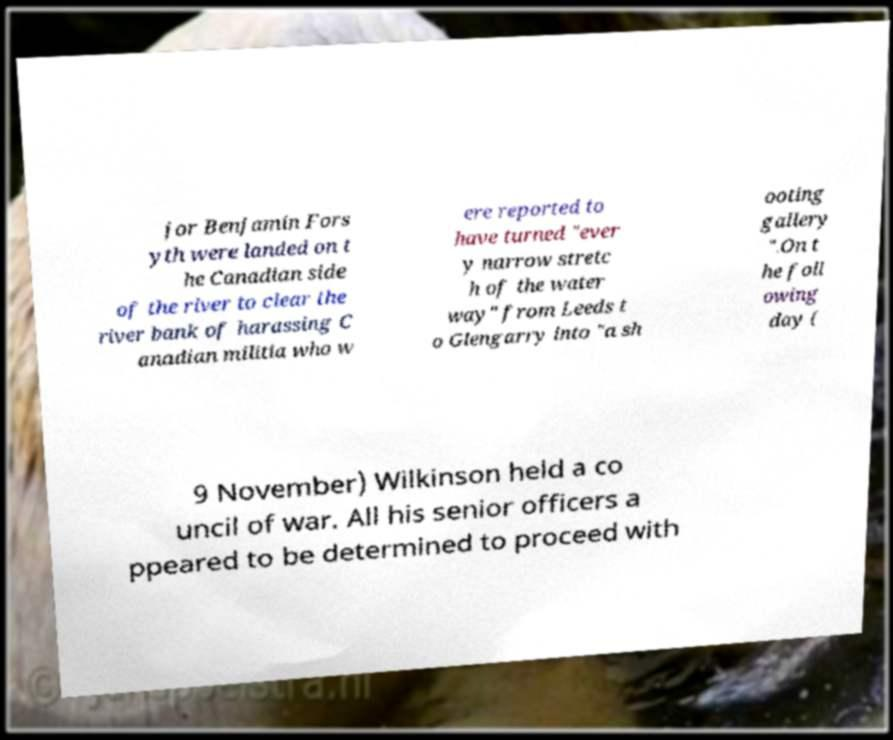Can you accurately transcribe the text from the provided image for me? jor Benjamin Fors yth were landed on t he Canadian side of the river to clear the river bank of harassing C anadian militia who w ere reported to have turned "ever y narrow stretc h of the water way" from Leeds t o Glengarry into "a sh ooting gallery ".On t he foll owing day ( 9 November) Wilkinson held a co uncil of war. All his senior officers a ppeared to be determined to proceed with 